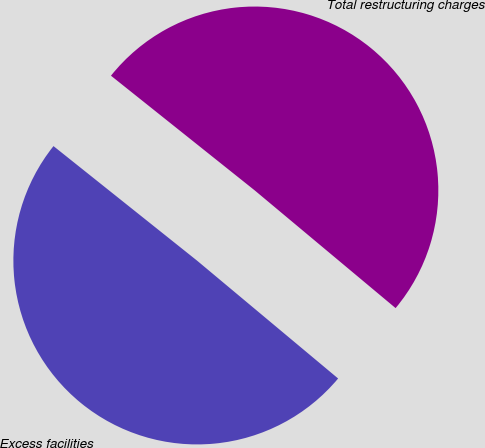Convert chart. <chart><loc_0><loc_0><loc_500><loc_500><pie_chart><fcel>Excess facilities<fcel>Total restructuring charges<nl><fcel>49.64%<fcel>50.36%<nl></chart> 